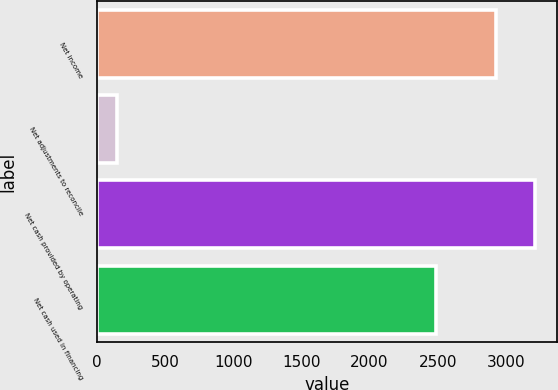Convert chart. <chart><loc_0><loc_0><loc_500><loc_500><bar_chart><fcel>Net income<fcel>Net adjustments to reconcile<fcel>Net cash provided by operating<fcel>Net cash used in financing<nl><fcel>2924<fcel>149<fcel>3216.4<fcel>2491<nl></chart> 